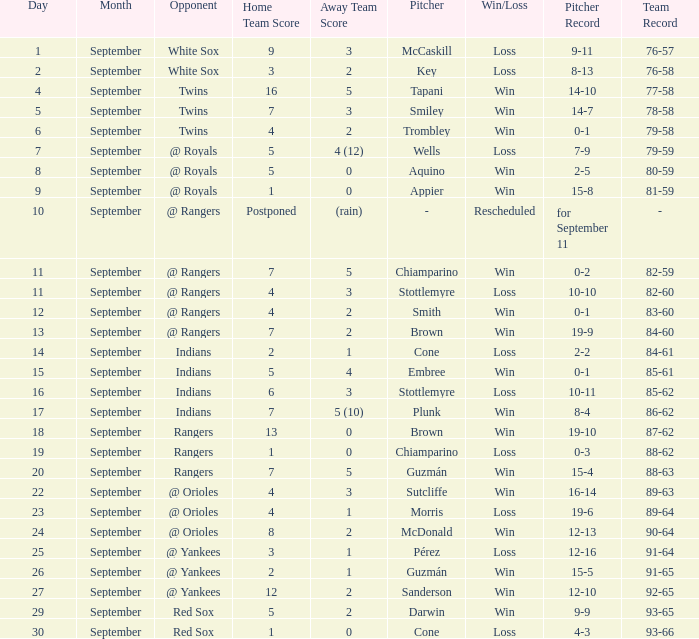What opponent has a loss of McCaskill (9-11)? White Sox. 